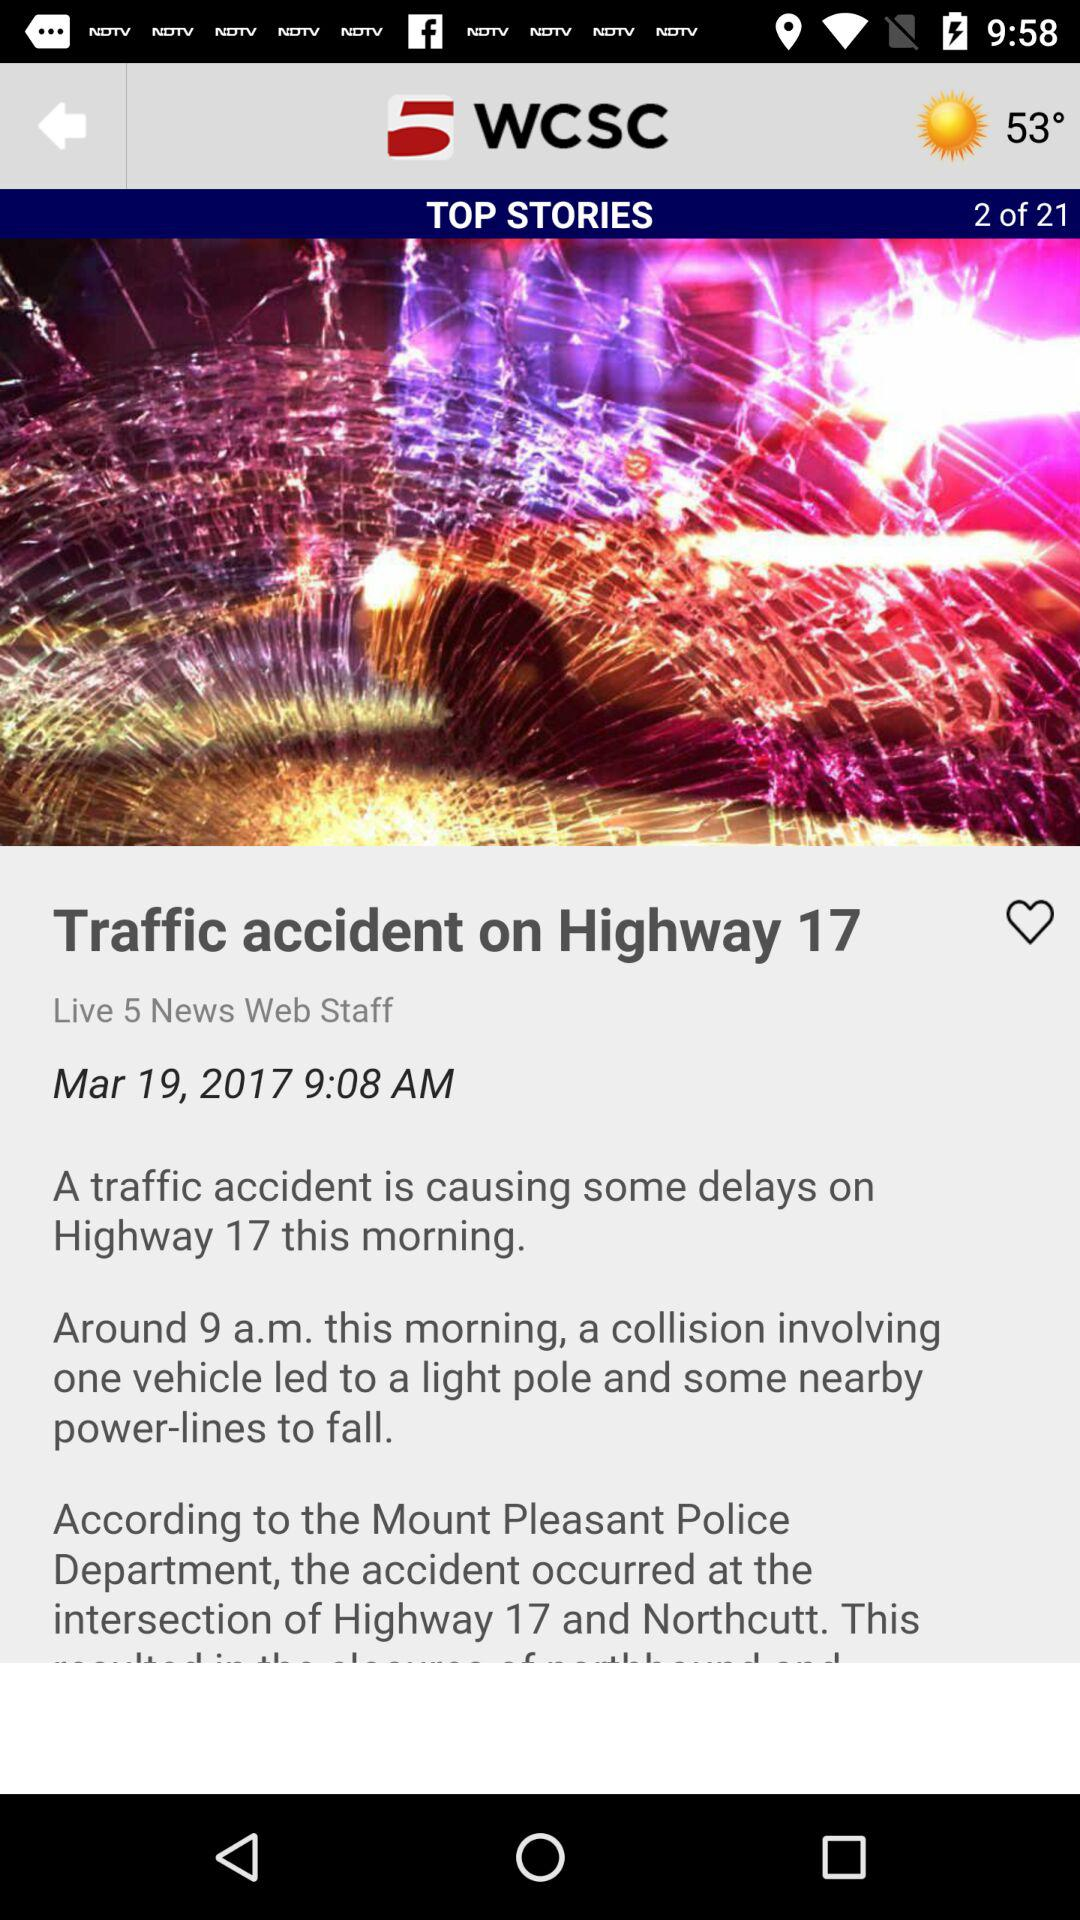How many total stories are there? There are 21 stories in total. 